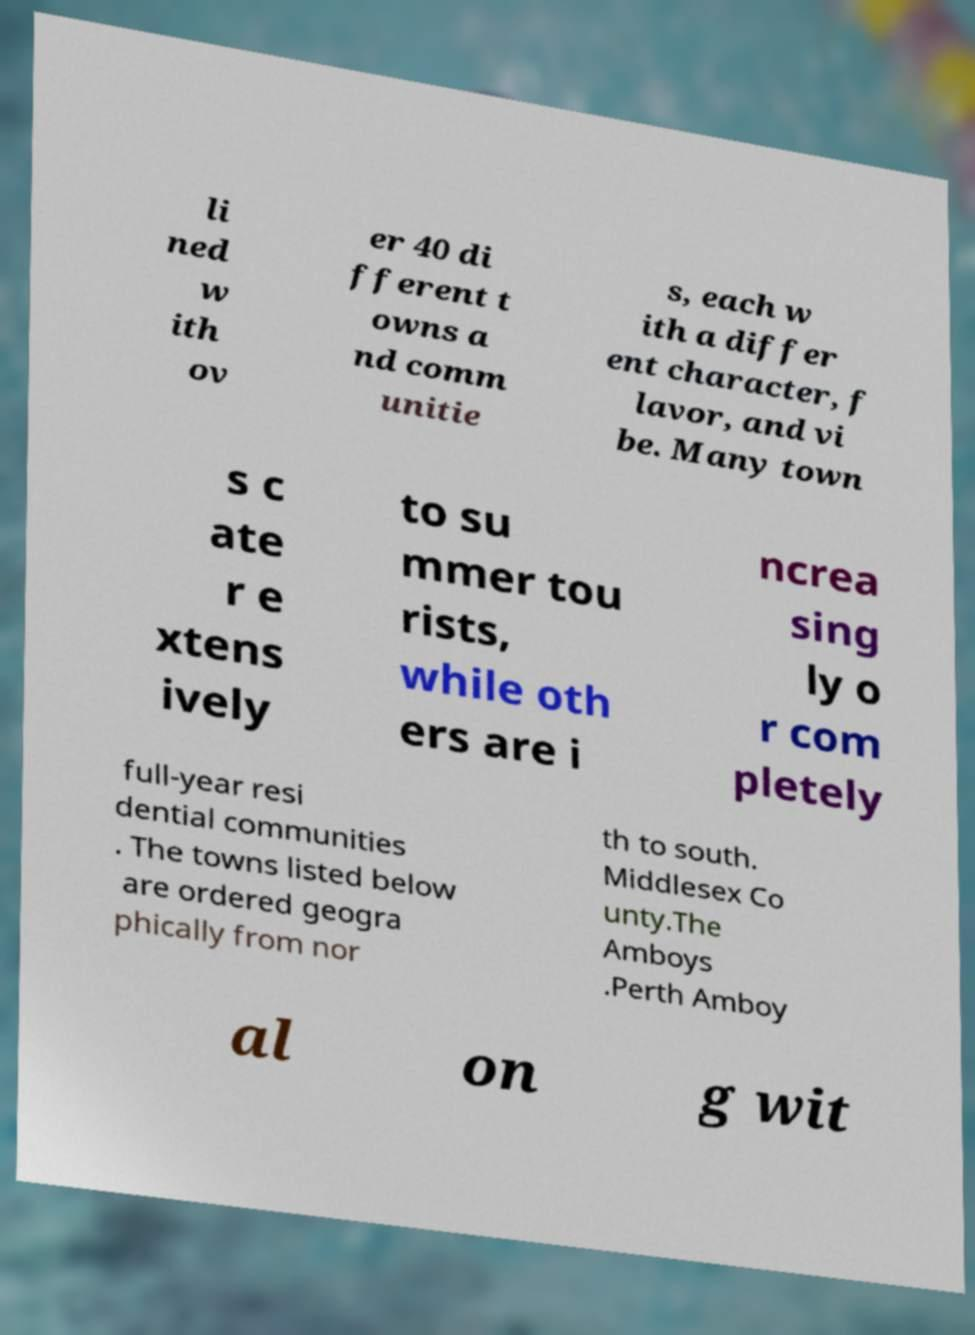Can you accurately transcribe the text from the provided image for me? li ned w ith ov er 40 di fferent t owns a nd comm unitie s, each w ith a differ ent character, f lavor, and vi be. Many town s c ate r e xtens ively to su mmer tou rists, while oth ers are i ncrea sing ly o r com pletely full-year resi dential communities . The towns listed below are ordered geogra phically from nor th to south. Middlesex Co unty.The Amboys .Perth Amboy al on g wit 